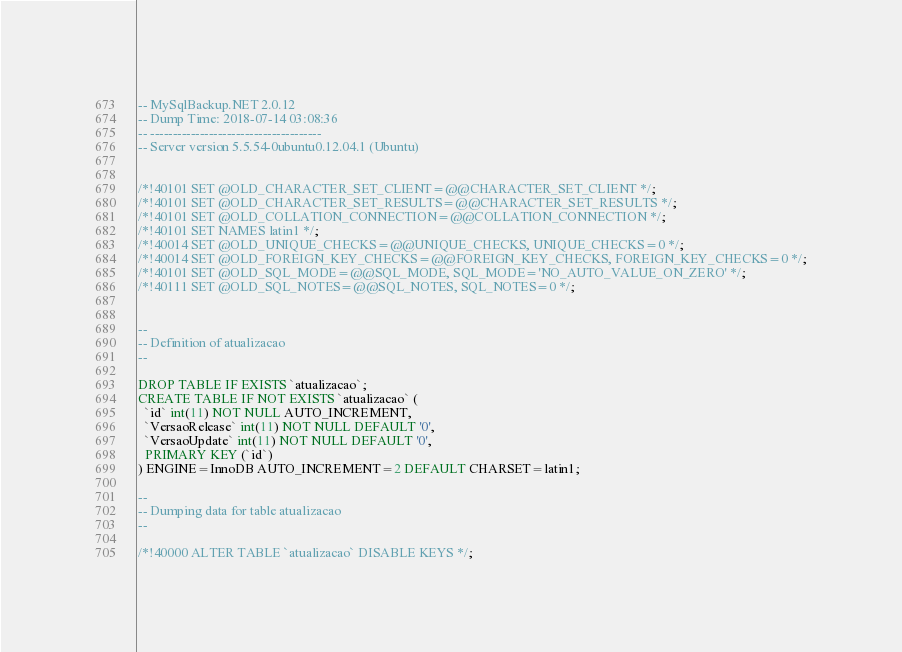Convert code to text. <code><loc_0><loc_0><loc_500><loc_500><_SQL_>-- MySqlBackup.NET 2.0.12
-- Dump Time: 2018-07-14 03:08:36
-- --------------------------------------
-- Server version 5.5.54-0ubuntu0.12.04.1 (Ubuntu)


/*!40101 SET @OLD_CHARACTER_SET_CLIENT=@@CHARACTER_SET_CLIENT */;
/*!40101 SET @OLD_CHARACTER_SET_RESULTS=@@CHARACTER_SET_RESULTS */;
/*!40101 SET @OLD_COLLATION_CONNECTION=@@COLLATION_CONNECTION */;
/*!40101 SET NAMES latin1 */;
/*!40014 SET @OLD_UNIQUE_CHECKS=@@UNIQUE_CHECKS, UNIQUE_CHECKS=0 */;
/*!40014 SET @OLD_FOREIGN_KEY_CHECKS=@@FOREIGN_KEY_CHECKS, FOREIGN_KEY_CHECKS=0 */;
/*!40101 SET @OLD_SQL_MODE=@@SQL_MODE, SQL_MODE='NO_AUTO_VALUE_ON_ZERO' */;
/*!40111 SET @OLD_SQL_NOTES=@@SQL_NOTES, SQL_NOTES=0 */;


-- 
-- Definition of atualizacao
-- 

DROP TABLE IF EXISTS `atualizacao`;
CREATE TABLE IF NOT EXISTS `atualizacao` (
  `id` int(11) NOT NULL AUTO_INCREMENT,
  `VersaoRelease` int(11) NOT NULL DEFAULT '0',
  `VersaoUpdate` int(11) NOT NULL DEFAULT '0',
  PRIMARY KEY (`id`)
) ENGINE=InnoDB AUTO_INCREMENT=2 DEFAULT CHARSET=latin1;

-- 
-- Dumping data for table atualizacao
-- 

/*!40000 ALTER TABLE `atualizacao` DISABLE KEYS */;</code> 